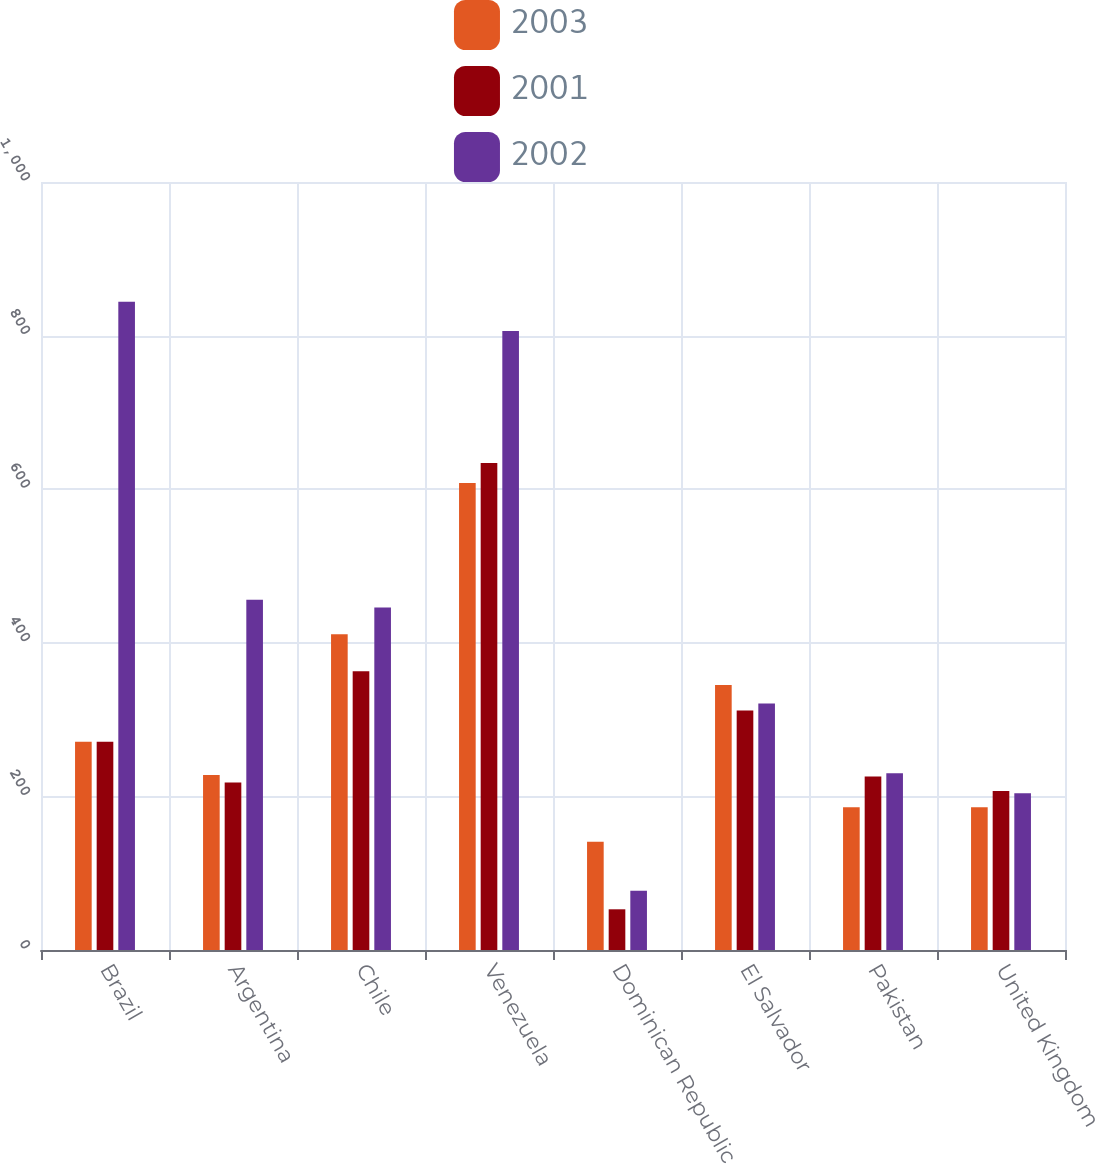Convert chart to OTSL. <chart><loc_0><loc_0><loc_500><loc_500><stacked_bar_chart><ecel><fcel>Brazil<fcel>Argentina<fcel>Chile<fcel>Venezuela<fcel>Dominican Republic<fcel>El Salvador<fcel>Pakistan<fcel>United Kingdom<nl><fcel>2003<fcel>271<fcel>228<fcel>411<fcel>608<fcel>141<fcel>345<fcel>186<fcel>186<nl><fcel>2001<fcel>271<fcel>218<fcel>363<fcel>634<fcel>53<fcel>312<fcel>226<fcel>207<nl><fcel>2002<fcel>844<fcel>456<fcel>446<fcel>806<fcel>77<fcel>321<fcel>230<fcel>204<nl></chart> 